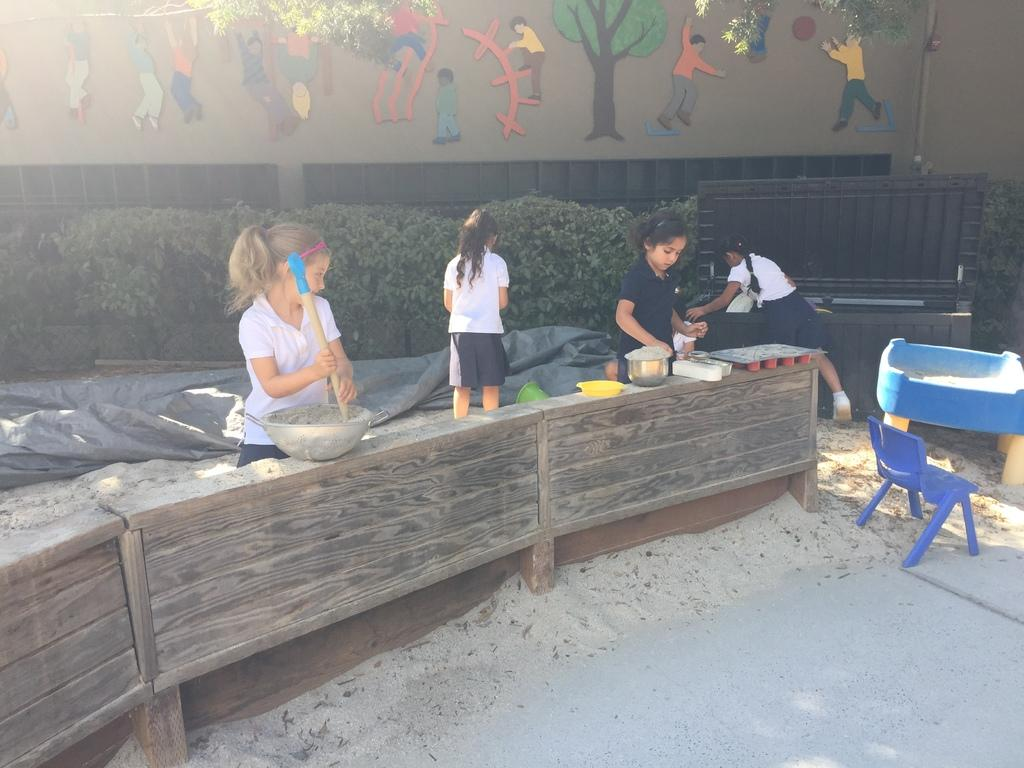How many people are standing in the image? There are 4 people standing in the image. What is in front of the people? There is a blue color chair in front of the people. What type of vegetation can be seen in the image? There are plants visible in the image. What is visible in the background of the image? There is a wall in the background of the image. What is depicted on the wall? Trees and persons are present on the wall. What type of berry is being used as a body part by one of the persons on the wall? There is no berry present in the image, and no person on the wall is using a berry as a body part. 